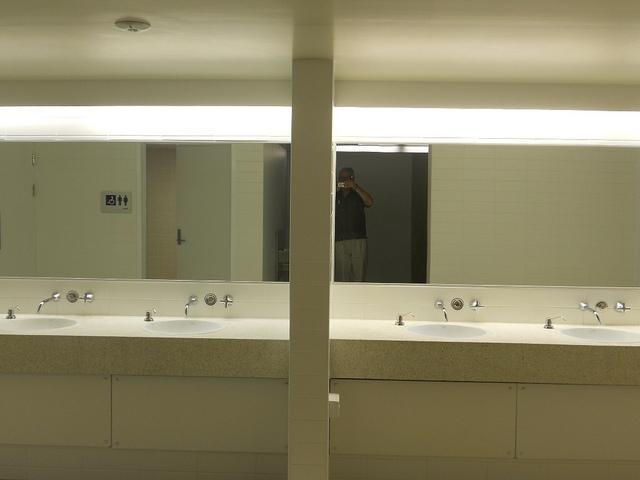What bathroom is it on the right?
Pick the correct solution from the four options below to address the question.
Options: Women, handicapped, transgender woman, men. Men. 